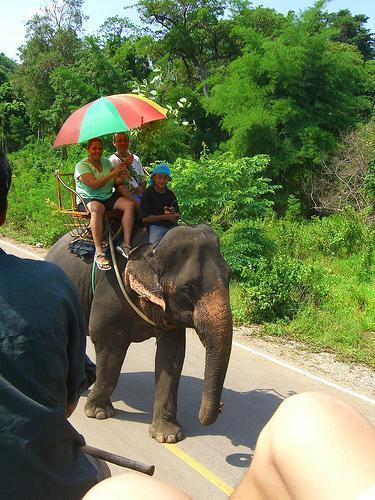How many elephants are there?
Give a very brief answer. 1. How many animals are pictured?
Give a very brief answer. 1. How many people are riding the elephant?
Give a very brief answer. 3. How many people are in the photo?
Give a very brief answer. 4. 